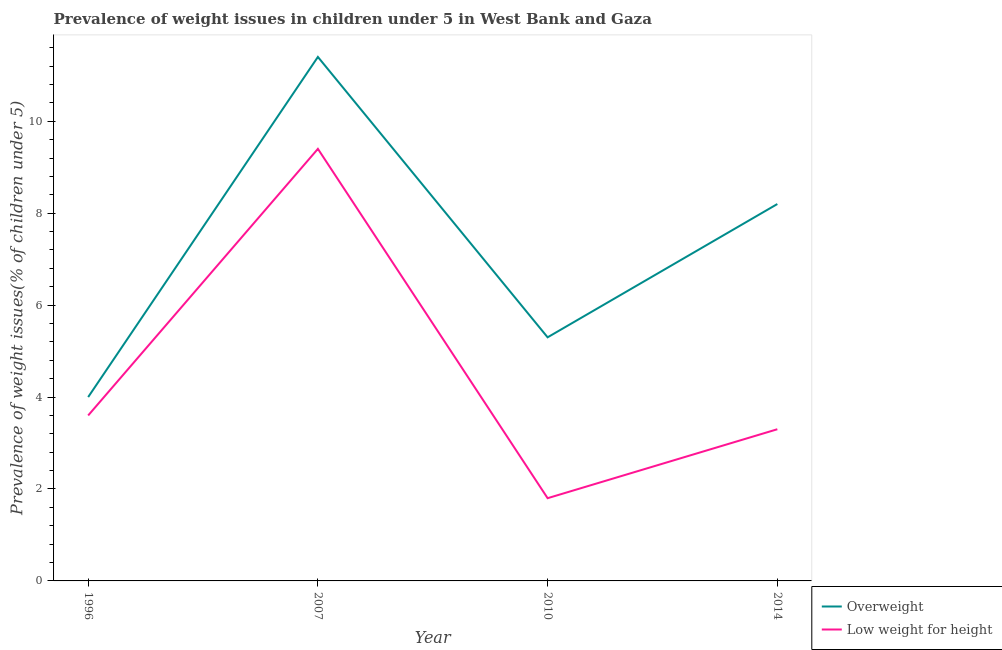How many different coloured lines are there?
Make the answer very short. 2. Does the line corresponding to percentage of overweight children intersect with the line corresponding to percentage of underweight children?
Give a very brief answer. No. What is the percentage of underweight children in 1996?
Give a very brief answer. 3.6. Across all years, what is the maximum percentage of overweight children?
Your response must be concise. 11.4. Across all years, what is the minimum percentage of underweight children?
Offer a terse response. 1.8. In which year was the percentage of overweight children maximum?
Ensure brevity in your answer.  2007. What is the total percentage of overweight children in the graph?
Your answer should be compact. 28.9. What is the difference between the percentage of underweight children in 1996 and that in 2014?
Keep it short and to the point. 0.3. What is the difference between the percentage of underweight children in 1996 and the percentage of overweight children in 2010?
Provide a succinct answer. -1.7. What is the average percentage of underweight children per year?
Offer a terse response. 4.52. In the year 2010, what is the difference between the percentage of underweight children and percentage of overweight children?
Offer a very short reply. -3.5. What is the ratio of the percentage of overweight children in 1996 to that in 2010?
Your response must be concise. 0.75. Is the percentage of overweight children in 2007 less than that in 2014?
Give a very brief answer. No. Is the difference between the percentage of underweight children in 2010 and 2014 greater than the difference between the percentage of overweight children in 2010 and 2014?
Provide a succinct answer. Yes. What is the difference between the highest and the second highest percentage of overweight children?
Make the answer very short. 3.2. What is the difference between the highest and the lowest percentage of overweight children?
Provide a succinct answer. 7.4. Does the percentage of underweight children monotonically increase over the years?
Your response must be concise. No. Is the percentage of underweight children strictly greater than the percentage of overweight children over the years?
Provide a succinct answer. No. Is the percentage of underweight children strictly less than the percentage of overweight children over the years?
Ensure brevity in your answer.  Yes. How many lines are there?
Your response must be concise. 2. What is the difference between two consecutive major ticks on the Y-axis?
Offer a terse response. 2. Are the values on the major ticks of Y-axis written in scientific E-notation?
Keep it short and to the point. No. Does the graph contain any zero values?
Provide a succinct answer. No. Where does the legend appear in the graph?
Keep it short and to the point. Bottom right. What is the title of the graph?
Give a very brief answer. Prevalence of weight issues in children under 5 in West Bank and Gaza. What is the label or title of the Y-axis?
Your answer should be very brief. Prevalence of weight issues(% of children under 5). What is the Prevalence of weight issues(% of children under 5) in Low weight for height in 1996?
Offer a very short reply. 3.6. What is the Prevalence of weight issues(% of children under 5) in Overweight in 2007?
Offer a very short reply. 11.4. What is the Prevalence of weight issues(% of children under 5) in Low weight for height in 2007?
Offer a terse response. 9.4. What is the Prevalence of weight issues(% of children under 5) of Overweight in 2010?
Keep it short and to the point. 5.3. What is the Prevalence of weight issues(% of children under 5) of Low weight for height in 2010?
Your response must be concise. 1.8. What is the Prevalence of weight issues(% of children under 5) in Overweight in 2014?
Provide a succinct answer. 8.2. What is the Prevalence of weight issues(% of children under 5) of Low weight for height in 2014?
Ensure brevity in your answer.  3.3. Across all years, what is the maximum Prevalence of weight issues(% of children under 5) of Overweight?
Offer a terse response. 11.4. Across all years, what is the maximum Prevalence of weight issues(% of children under 5) in Low weight for height?
Provide a short and direct response. 9.4. Across all years, what is the minimum Prevalence of weight issues(% of children under 5) of Low weight for height?
Provide a short and direct response. 1.8. What is the total Prevalence of weight issues(% of children under 5) of Overweight in the graph?
Your response must be concise. 28.9. What is the difference between the Prevalence of weight issues(% of children under 5) in Overweight in 1996 and that in 2007?
Keep it short and to the point. -7.4. What is the difference between the Prevalence of weight issues(% of children under 5) in Low weight for height in 1996 and that in 2010?
Your response must be concise. 1.8. What is the difference between the Prevalence of weight issues(% of children under 5) in Overweight in 1996 and that in 2014?
Keep it short and to the point. -4.2. What is the difference between the Prevalence of weight issues(% of children under 5) of Low weight for height in 1996 and that in 2014?
Your answer should be very brief. 0.3. What is the difference between the Prevalence of weight issues(% of children under 5) of Low weight for height in 2007 and that in 2010?
Your answer should be very brief. 7.6. What is the difference between the Prevalence of weight issues(% of children under 5) of Overweight in 2010 and that in 2014?
Make the answer very short. -2.9. What is the difference between the Prevalence of weight issues(% of children under 5) of Overweight in 1996 and the Prevalence of weight issues(% of children under 5) of Low weight for height in 2010?
Your answer should be very brief. 2.2. What is the difference between the Prevalence of weight issues(% of children under 5) in Overweight in 1996 and the Prevalence of weight issues(% of children under 5) in Low weight for height in 2014?
Your response must be concise. 0.7. What is the difference between the Prevalence of weight issues(% of children under 5) of Overweight in 2010 and the Prevalence of weight issues(% of children under 5) of Low weight for height in 2014?
Provide a succinct answer. 2. What is the average Prevalence of weight issues(% of children under 5) of Overweight per year?
Ensure brevity in your answer.  7.22. What is the average Prevalence of weight issues(% of children under 5) of Low weight for height per year?
Provide a short and direct response. 4.53. In the year 2010, what is the difference between the Prevalence of weight issues(% of children under 5) in Overweight and Prevalence of weight issues(% of children under 5) in Low weight for height?
Ensure brevity in your answer.  3.5. What is the ratio of the Prevalence of weight issues(% of children under 5) of Overweight in 1996 to that in 2007?
Your answer should be compact. 0.35. What is the ratio of the Prevalence of weight issues(% of children under 5) of Low weight for height in 1996 to that in 2007?
Provide a succinct answer. 0.38. What is the ratio of the Prevalence of weight issues(% of children under 5) of Overweight in 1996 to that in 2010?
Offer a terse response. 0.75. What is the ratio of the Prevalence of weight issues(% of children under 5) of Low weight for height in 1996 to that in 2010?
Provide a short and direct response. 2. What is the ratio of the Prevalence of weight issues(% of children under 5) of Overweight in 1996 to that in 2014?
Provide a succinct answer. 0.49. What is the ratio of the Prevalence of weight issues(% of children under 5) in Low weight for height in 1996 to that in 2014?
Your answer should be compact. 1.09. What is the ratio of the Prevalence of weight issues(% of children under 5) in Overweight in 2007 to that in 2010?
Your answer should be very brief. 2.15. What is the ratio of the Prevalence of weight issues(% of children under 5) of Low weight for height in 2007 to that in 2010?
Make the answer very short. 5.22. What is the ratio of the Prevalence of weight issues(% of children under 5) of Overweight in 2007 to that in 2014?
Offer a terse response. 1.39. What is the ratio of the Prevalence of weight issues(% of children under 5) of Low weight for height in 2007 to that in 2014?
Your answer should be very brief. 2.85. What is the ratio of the Prevalence of weight issues(% of children under 5) in Overweight in 2010 to that in 2014?
Provide a succinct answer. 0.65. What is the ratio of the Prevalence of weight issues(% of children under 5) of Low weight for height in 2010 to that in 2014?
Provide a short and direct response. 0.55. What is the difference between the highest and the second highest Prevalence of weight issues(% of children under 5) in Low weight for height?
Ensure brevity in your answer.  5.8. 